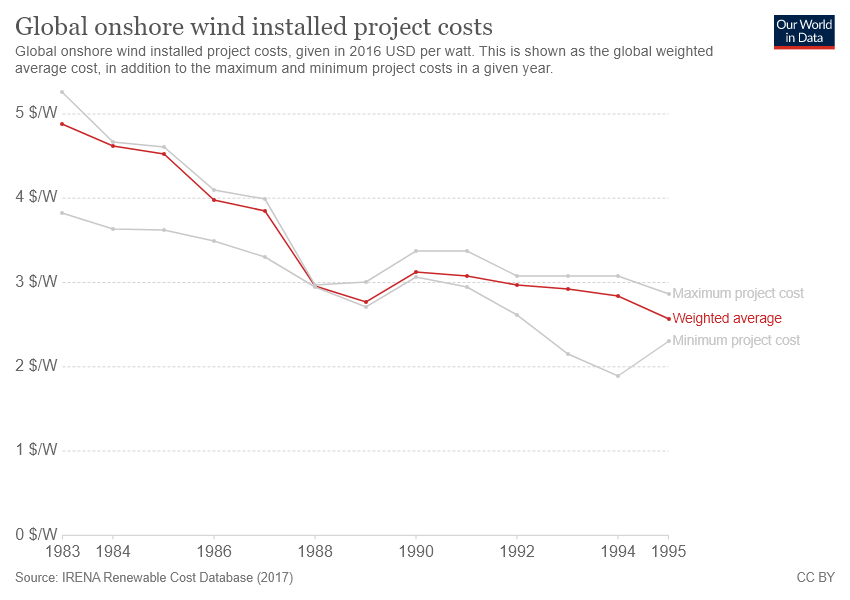Identify some key points in this picture. There are two gray color bars shown in the graph. The bars in the graph will meet in the year 1988. 